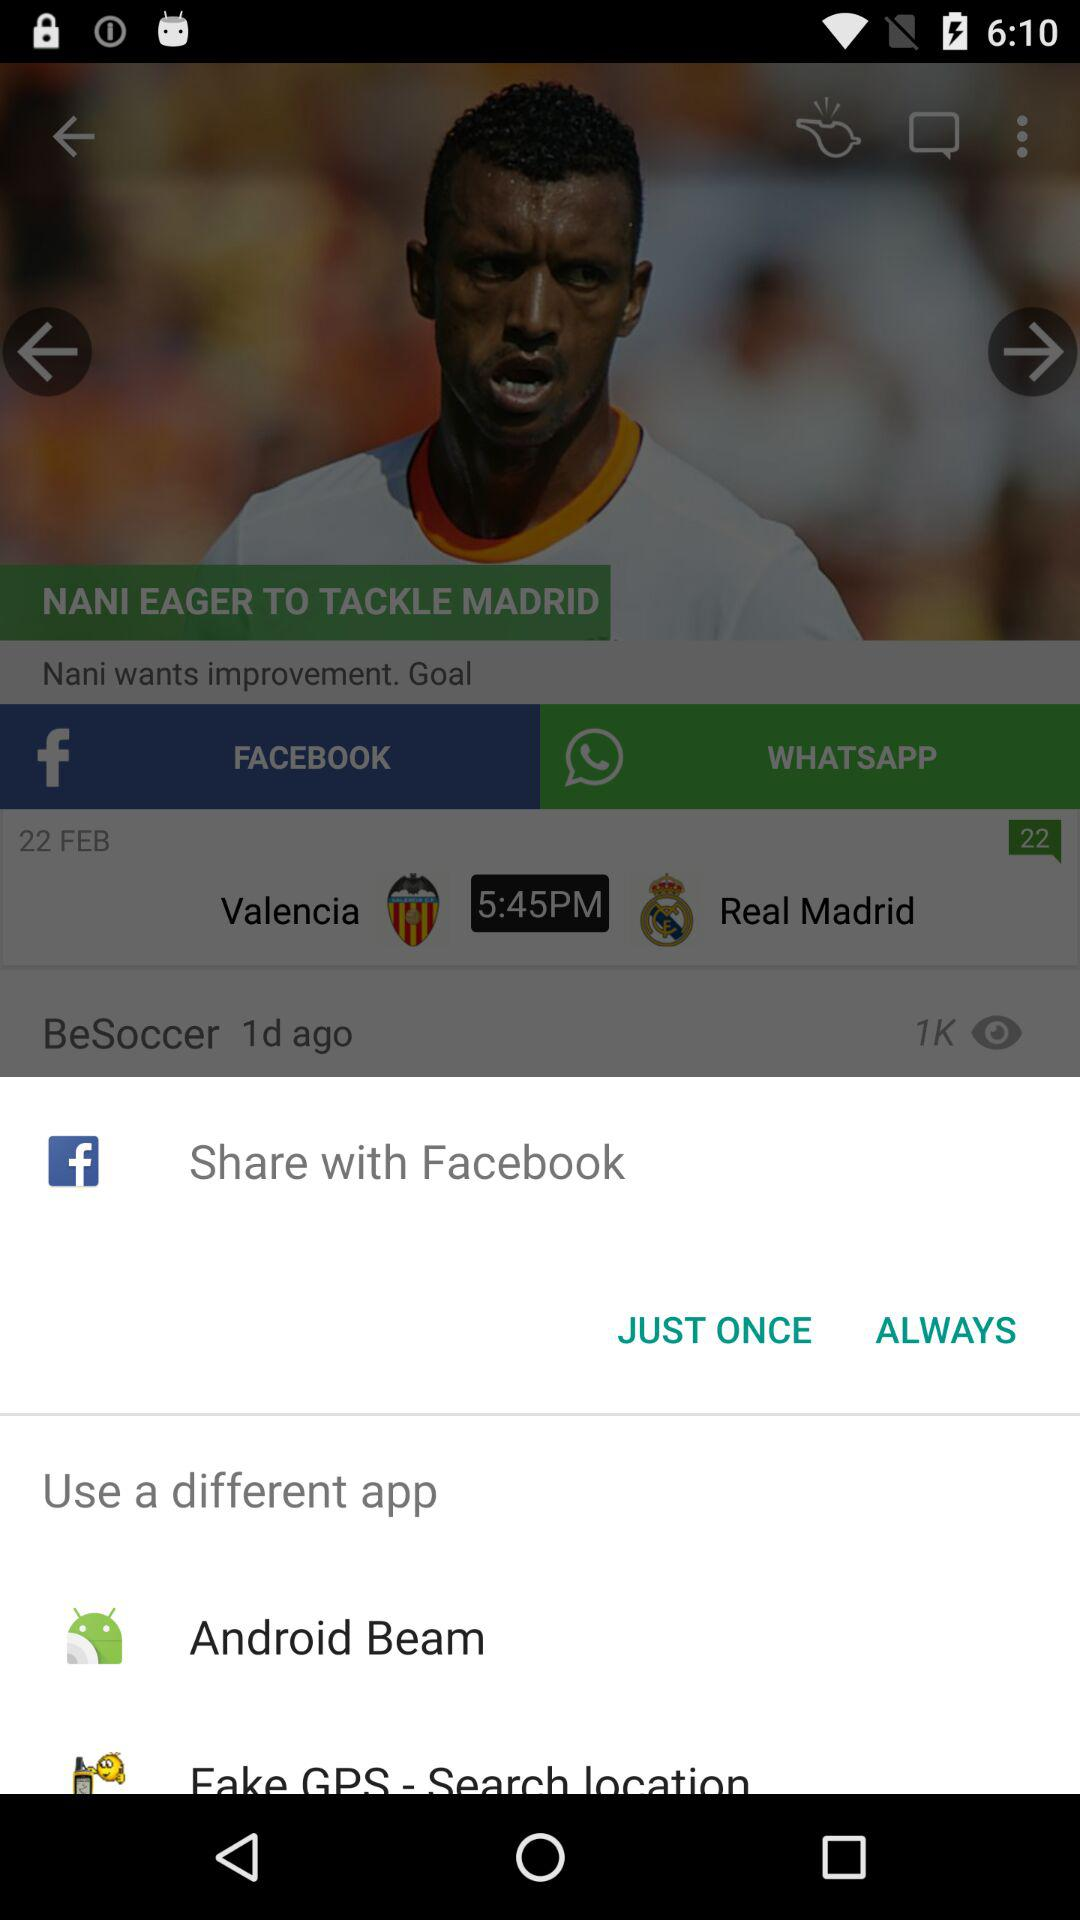Which options are given for sharing? The options given for sharing are "Facebook" and "Android Beam". 